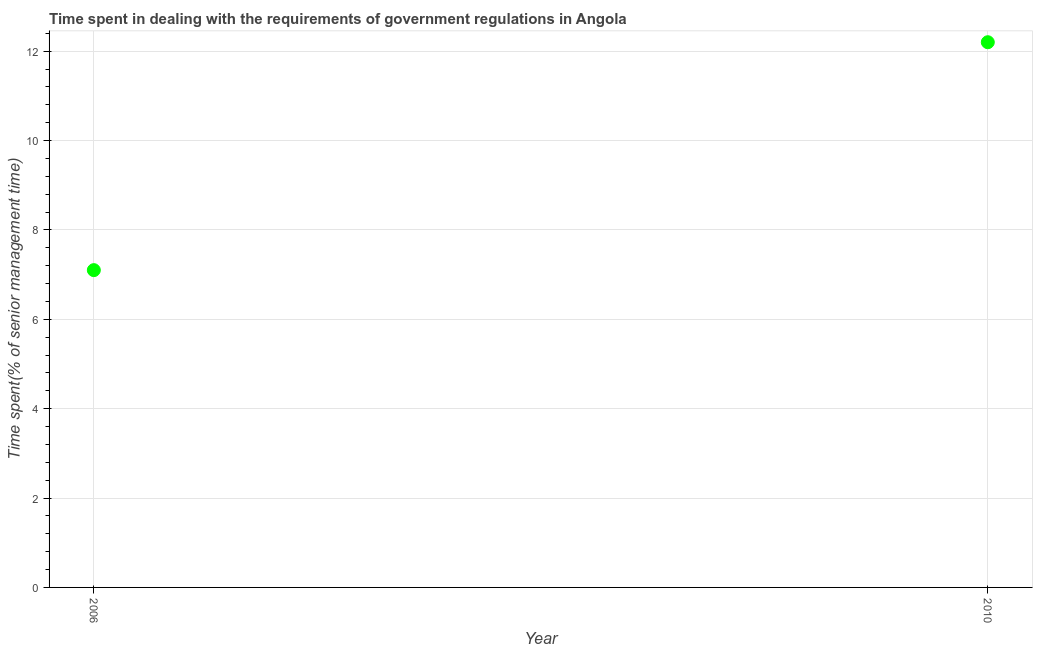Across all years, what is the minimum time spent in dealing with government regulations?
Your answer should be very brief. 7.1. In which year was the time spent in dealing with government regulations maximum?
Provide a short and direct response. 2010. What is the sum of the time spent in dealing with government regulations?
Your answer should be very brief. 19.3. What is the difference between the time spent in dealing with government regulations in 2006 and 2010?
Ensure brevity in your answer.  -5.1. What is the average time spent in dealing with government regulations per year?
Offer a terse response. 9.65. What is the median time spent in dealing with government regulations?
Offer a very short reply. 9.65. Do a majority of the years between 2006 and 2010 (inclusive) have time spent in dealing with government regulations greater than 0.4 %?
Offer a terse response. Yes. What is the ratio of the time spent in dealing with government regulations in 2006 to that in 2010?
Offer a terse response. 0.58. Is the time spent in dealing with government regulations in 2006 less than that in 2010?
Provide a succinct answer. Yes. Are the values on the major ticks of Y-axis written in scientific E-notation?
Your response must be concise. No. Does the graph contain grids?
Offer a terse response. Yes. What is the title of the graph?
Offer a very short reply. Time spent in dealing with the requirements of government regulations in Angola. What is the label or title of the X-axis?
Your answer should be compact. Year. What is the label or title of the Y-axis?
Your answer should be compact. Time spent(% of senior management time). What is the Time spent(% of senior management time) in 2006?
Your answer should be compact. 7.1. What is the difference between the Time spent(% of senior management time) in 2006 and 2010?
Keep it short and to the point. -5.1. What is the ratio of the Time spent(% of senior management time) in 2006 to that in 2010?
Your answer should be very brief. 0.58. 